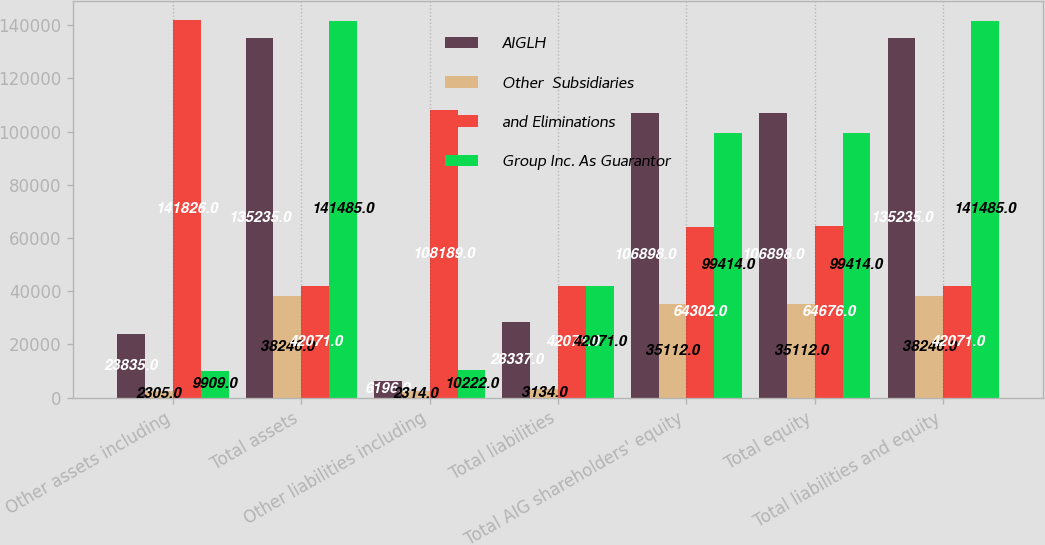Convert chart to OTSL. <chart><loc_0><loc_0><loc_500><loc_500><stacked_bar_chart><ecel><fcel>Other assets including<fcel>Total assets<fcel>Other liabilities including<fcel>Total liabilities<fcel>Total AIG shareholders' equity<fcel>Total equity<fcel>Total liabilities and equity<nl><fcel>AIGLH<fcel>23835<fcel>135235<fcel>6196<fcel>28337<fcel>106898<fcel>106898<fcel>135235<nl><fcel>Other  Subsidiaries<fcel>2305<fcel>38246<fcel>2314<fcel>3134<fcel>35112<fcel>35112<fcel>38246<nl><fcel>and Eliminations<fcel>141826<fcel>42071<fcel>108189<fcel>42071<fcel>64302<fcel>64676<fcel>42071<nl><fcel>Group Inc. As Guarantor<fcel>9909<fcel>141485<fcel>10222<fcel>42071<fcel>99414<fcel>99414<fcel>141485<nl></chart> 